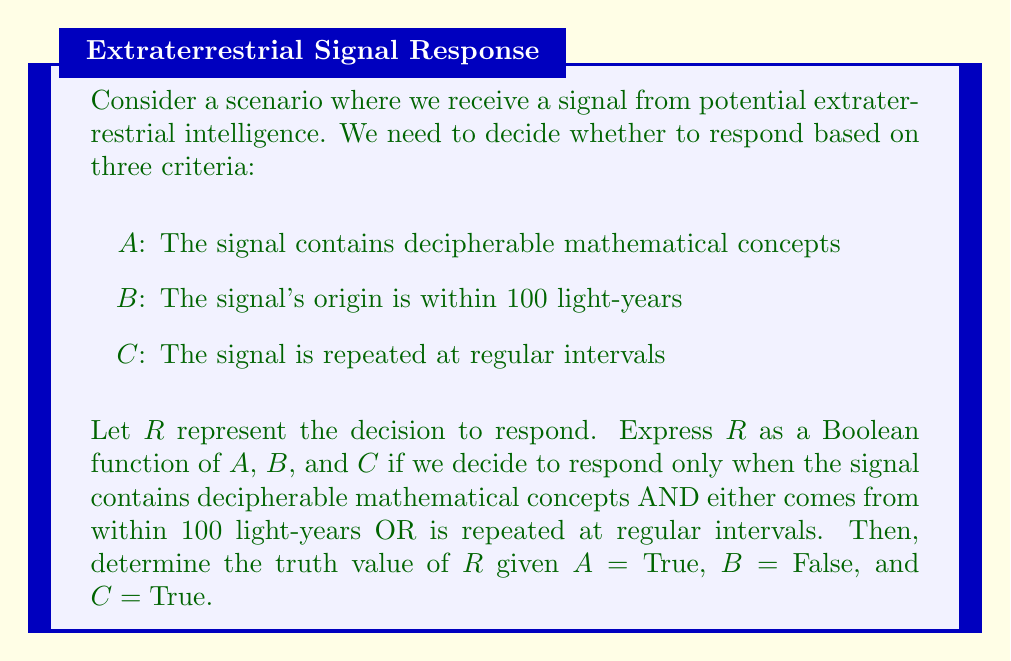Can you answer this question? 1. First, let's express the decision to respond (R) as a Boolean function of A, B, and C based on the given criteria:

   R = A AND (B OR C)

2. In Boolean algebra, this can be written as:

   $$ R = A \cdot (B + C) $$

3. Now, let's evaluate R given the truth values:
   A = True (1)
   B = False (0)
   C = True (1)

4. Substitute these values into our Boolean function:

   $$ R = 1 \cdot (0 + 1) $$

5. Evaluate the expression inside the parentheses:
   
   $$ R = 1 \cdot (1) $$

6. Multiply:

   $$ R = 1 $$

7. In Boolean algebra, 1 represents True.

Therefore, given the provided truth values, the decision to respond (R) is True.
Answer: True 